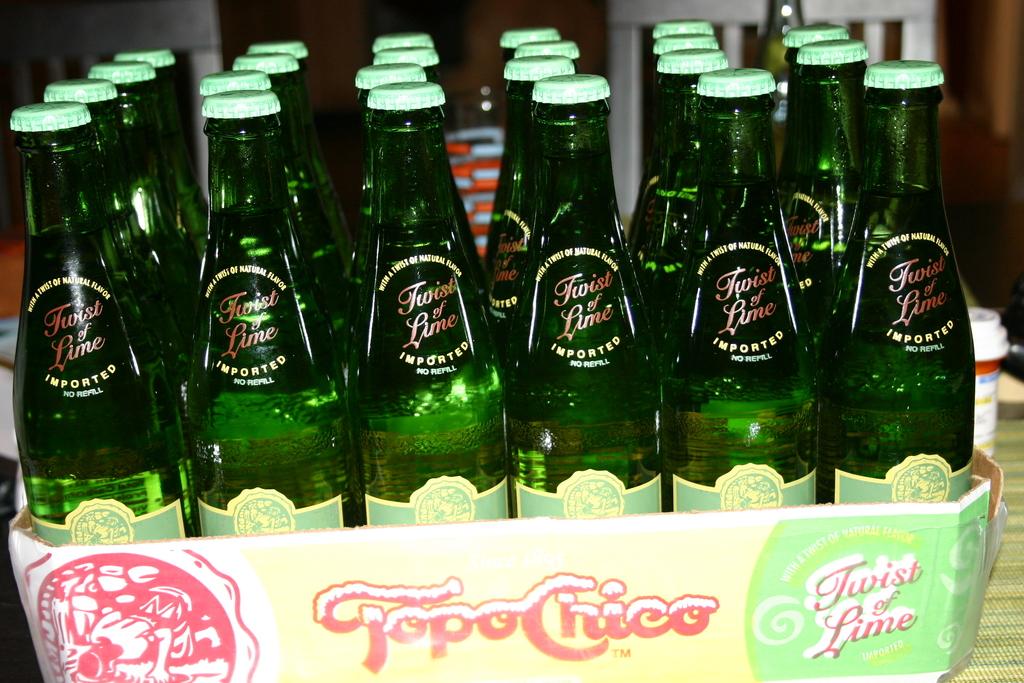The total in this package is?
Your answer should be compact. Answering does not require reading text in the image. 